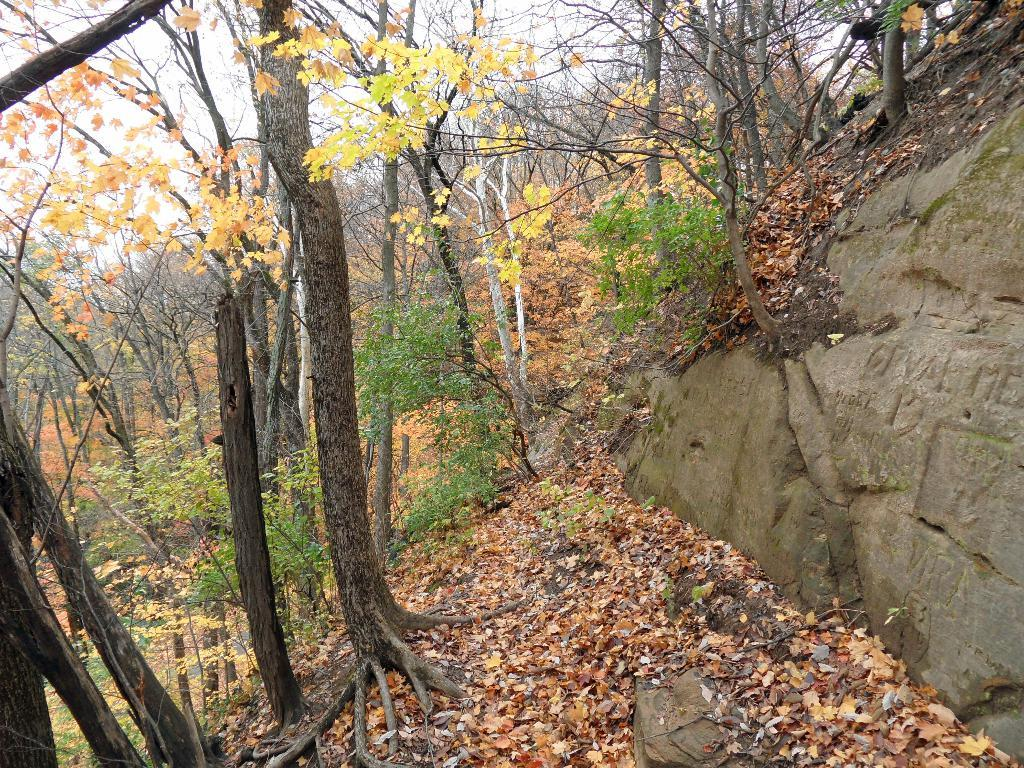What is the main object in the image? There is a rock in the image. What is covering the surface of the rock? There are leaves on the surface of the rock. What type of vegetation can be seen in the image? There are trees in the image. What is visible in the background of the image? The sky is visible in the image. What type of camera is being used to take the picture of the rock? There is no camera present in the image, as the image itself is being observed. Is there a hat visible on the rock in the image? No, there is no hat present on the rock in the image. 